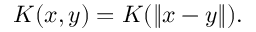Convert formula to latex. <formula><loc_0><loc_0><loc_500><loc_500>K ( x , y ) = K ( \| x - y \| ) .</formula> 